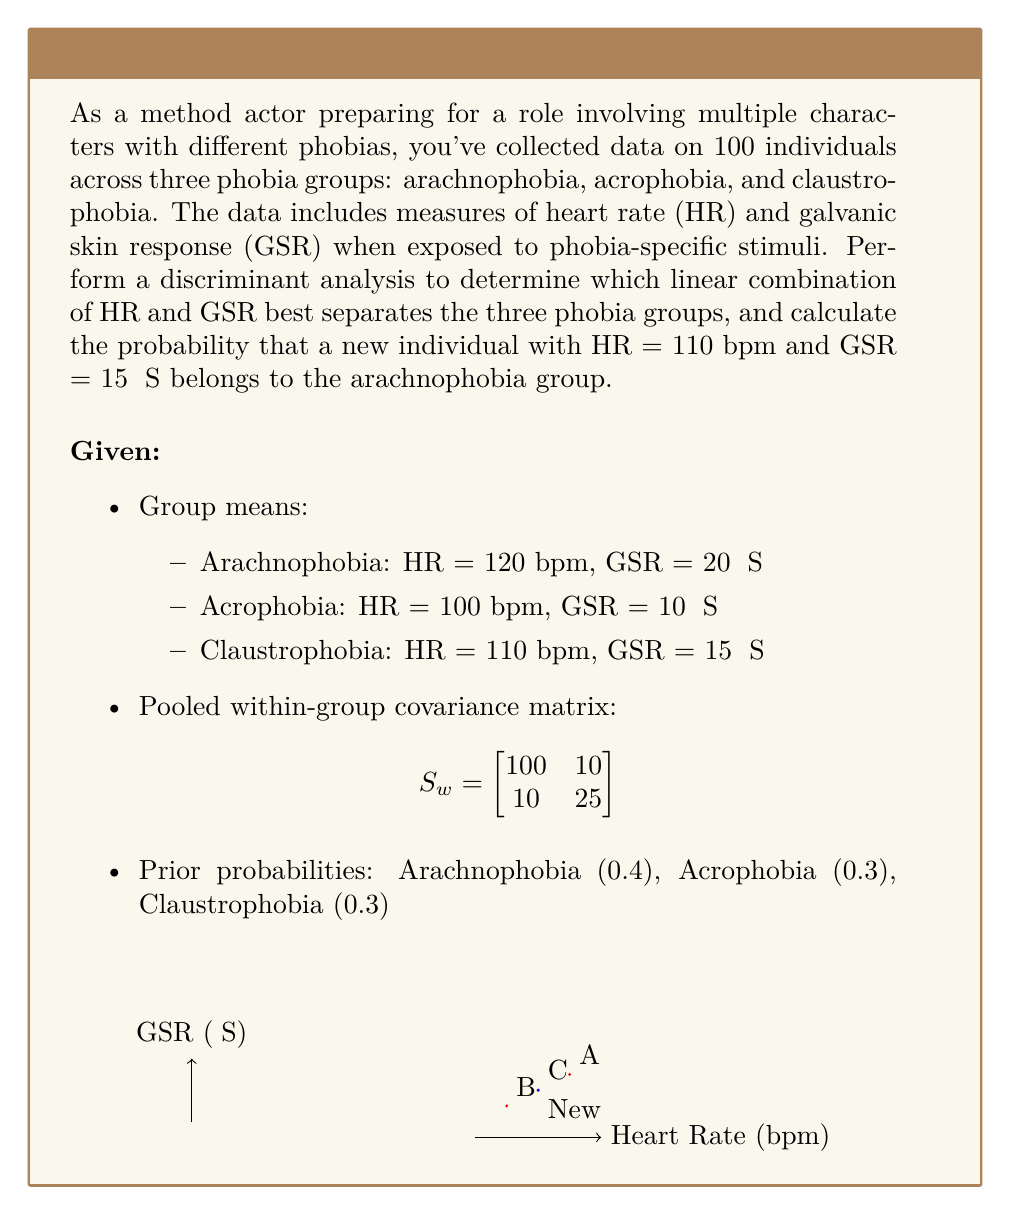Solve this math problem. To perform discriminant analysis and calculate the probability, we'll follow these steps:

1) Calculate the linear discriminant functions for each group:
   $$d_i(x) = \ln(p_i) - \frac{1}{2}\mu_i^T\Sigma^{-1}\mu_i + x^T\Sigma^{-1}\mu_i$$
   where $p_i$ is the prior probability, $\mu_i$ is the group mean vector, and $\Sigma^{-1}$ is the inverse of the pooled within-group covariance matrix.

2) First, we need to find $\Sigma^{-1}$:
   $$\Sigma^{-1} = S_w^{-1} = \frac{1}{100 \cdot 25 - 10 \cdot 10} \begin{bmatrix}
   25 & -10 \\
   -10 & 100
   \end{bmatrix} = \begin{bmatrix}
   0.01 & -0.004 \\
   -0.004 & 0.04
   \end{bmatrix}$$

3) Now, calculate $d_i(x)$ for each group:
   For Arachnophobia (A):
   $$d_A(x) = \ln(0.4) - \frac{1}{2}[120, 20]\begin{bmatrix}
   0.01 & -0.004 \\
   -0.004 & 0.04
   \end{bmatrix}\begin{bmatrix}
   120 \\
   20
   \end{bmatrix} + [x_1, x_2]\begin{bmatrix}
   0.01 & -0.004 \\
   -0.004 & 0.04
   \end{bmatrix}\begin{bmatrix}
   120 \\
   20
   \end{bmatrix}$$
   
   Similarly for Acrophobia (B) and Claustrophobia (C).

4) Evaluate $d_i(x)$ for the new individual (110, 15):
   $$d_A(110, 15) = -0.916 - 8.4 + 1.36 = -7.956$$
   $$d_B(110, 15) = -1.204 - 5.8 + 1.12 = -5.884$$
   $$d_C(110, 15) = -1.204 - 7.05 + 1.24 = -7.014$$

5) Calculate probabilities using the softmax function:
   $$P(A|x) = \frac{e^{d_A(x)}}{e^{d_A(x)} + e^{d_B(x)} + e^{d_C(x)}}$$

   $$P(A|110, 15) = \frac{e^{-7.956}}{e^{-7.956} + e^{-5.884} + e^{-7.014}} = 0.0872$$

Thus, the probability that the new individual belongs to the arachnophobia group is approximately 0.0872 or 8.72%.
Answer: 0.0872 